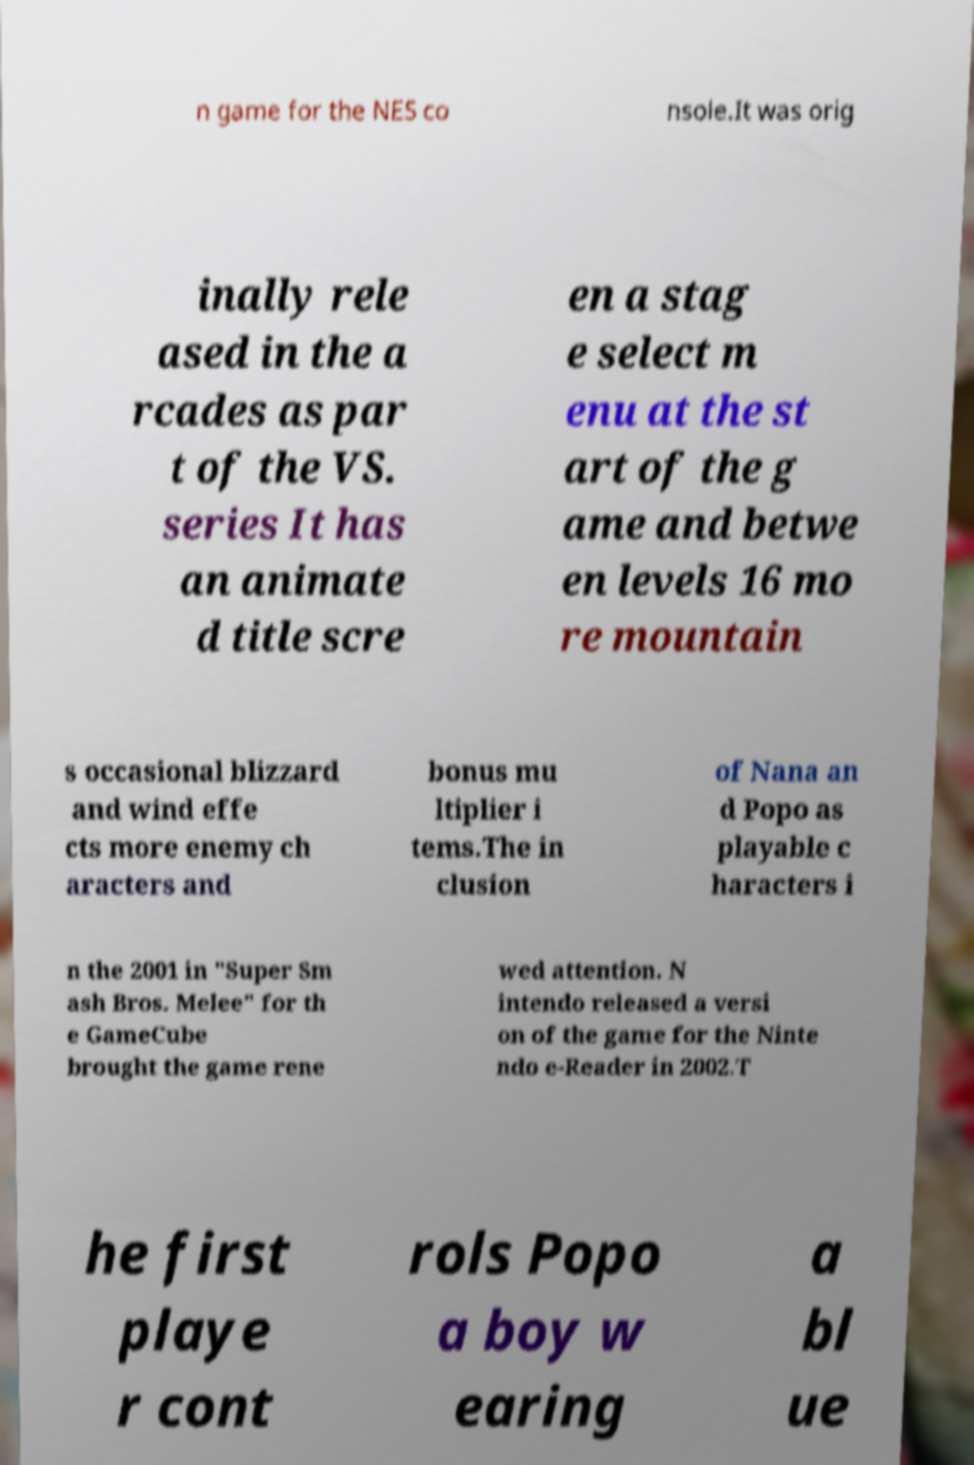Please identify and transcribe the text found in this image. n game for the NES co nsole.It was orig inally rele ased in the a rcades as par t of the VS. series It has an animate d title scre en a stag e select m enu at the st art of the g ame and betwe en levels 16 mo re mountain s occasional blizzard and wind effe cts more enemy ch aracters and bonus mu ltiplier i tems.The in clusion of Nana an d Popo as playable c haracters i n the 2001 in "Super Sm ash Bros. Melee" for th e GameCube brought the game rene wed attention. N intendo released a versi on of the game for the Ninte ndo e-Reader in 2002.T he first playe r cont rols Popo a boy w earing a bl ue 